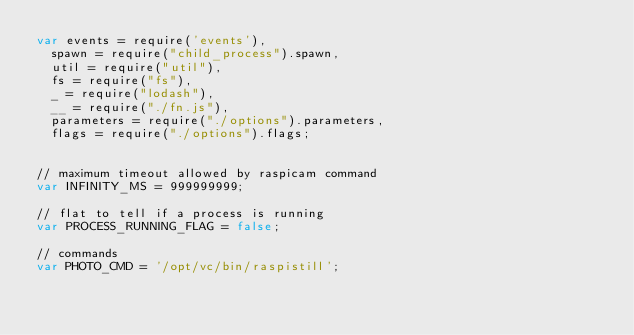<code> <loc_0><loc_0><loc_500><loc_500><_JavaScript_>var events = require('events'),
  spawn = require("child_process").spawn,
  util = require("util"),
  fs = require("fs"),
  _ = require("lodash"),
  __ = require("./fn.js"),
  parameters = require("./options").parameters,
  flags = require("./options").flags;


// maximum timeout allowed by raspicam command
var INFINITY_MS = 999999999;

// flat to tell if a process is running
var PROCESS_RUNNING_FLAG = false;

// commands
var PHOTO_CMD = '/opt/vc/bin/raspistill';</code> 